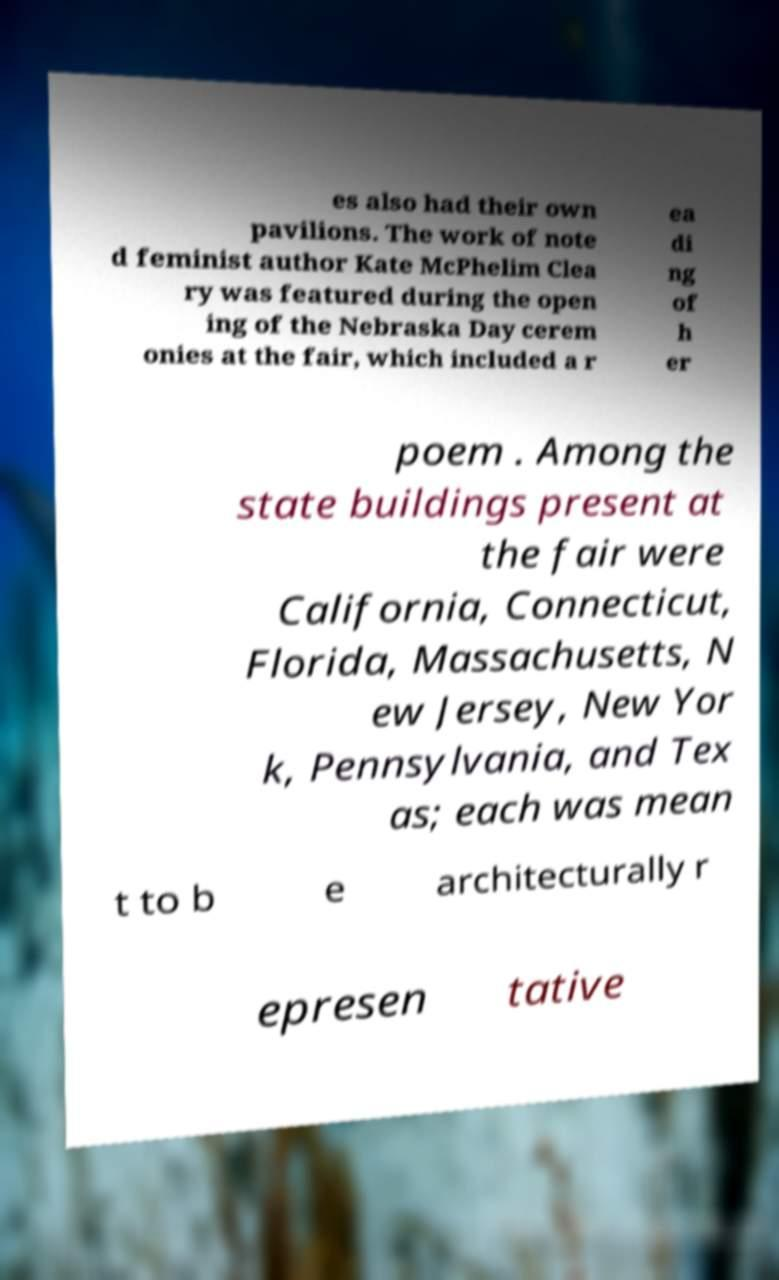Please identify and transcribe the text found in this image. es also had their own pavilions. The work of note d feminist author Kate McPhelim Clea ry was featured during the open ing of the Nebraska Day cerem onies at the fair, which included a r ea di ng of h er poem . Among the state buildings present at the fair were California, Connecticut, Florida, Massachusetts, N ew Jersey, New Yor k, Pennsylvania, and Tex as; each was mean t to b e architecturally r epresen tative 